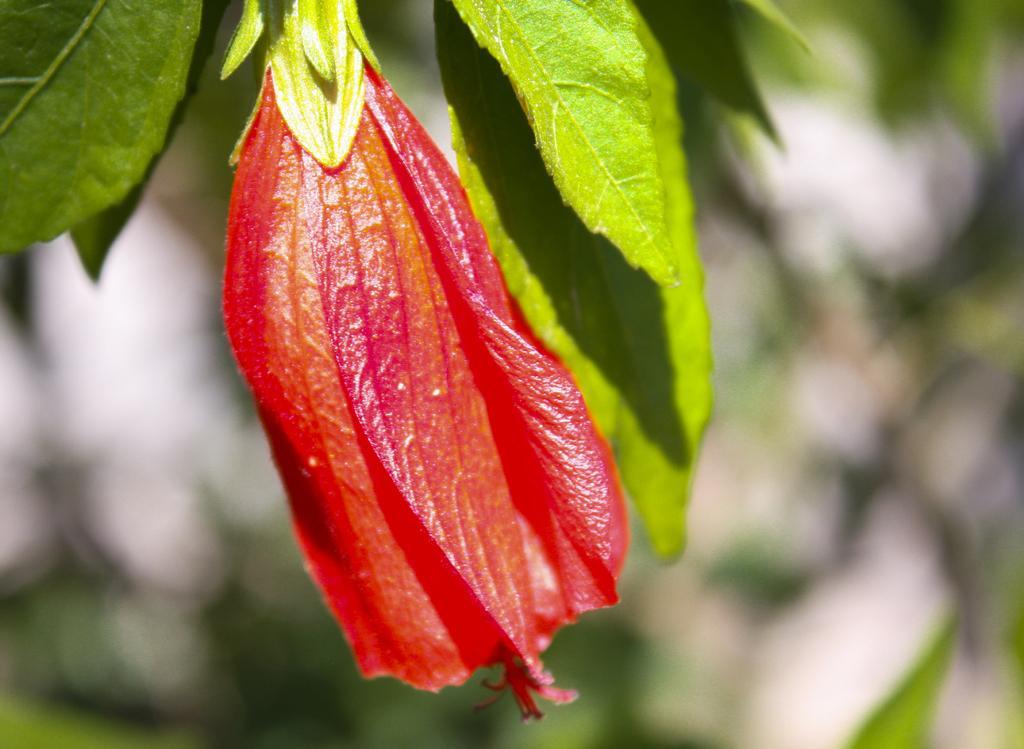Describe this image in one or two sentences. In this image in the front there is a flower and there are leaves and the background is blurry. 